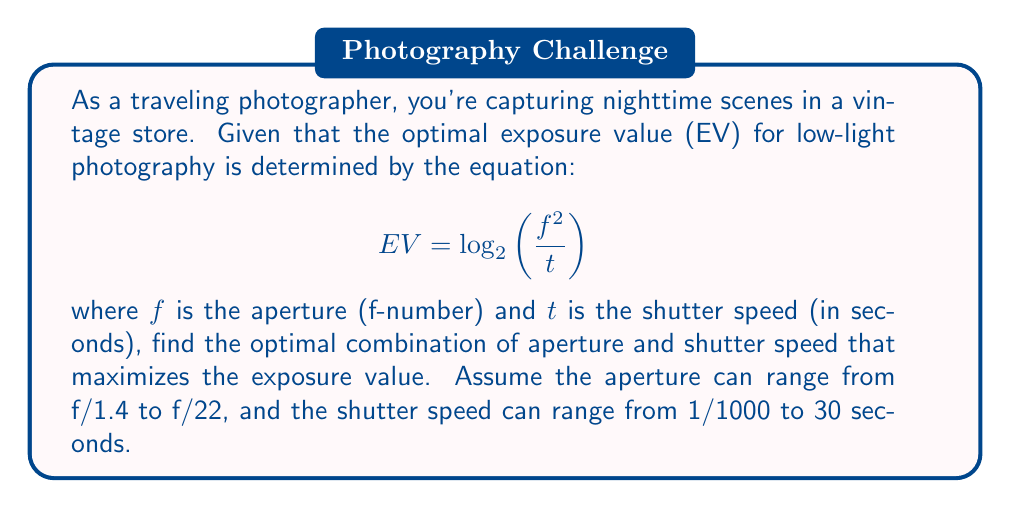Can you answer this question? To find the optimal combination of aperture and shutter speed, we need to maximize the exposure value (EV) function. Let's approach this step-by-step:

1) First, we express the EV function in terms of $f$ and $t$:

   $$EV(f,t) = \log_2\left(\frac{f^2}{t}\right)$$

2) To maximize this function, we need to find the partial derivatives with respect to $f$ and $t$ and set them equal to zero:

   $$\frac{\partial EV}{\partial f} = \frac{2}{f \ln 2} = 0$$
   $$\frac{\partial EV}{\partial t} = -\frac{1}{t \ln 2} = 0$$

3) From these equations, we can see that there are no finite values of $f$ and $t$ that satisfy both conditions simultaneously. This means that the maximum must occur at the boundaries of our allowed ranges.

4) Given the ranges:
   $1.4 \leq f \leq 22$
   $\frac{1}{1000} \leq t \leq 30$

5) To maximize EV, we need to maximize $\frac{f^2}{t}$. This occurs when $f$ is at its maximum and $t$ is at its minimum.

6) Therefore, the optimal values are:
   $f = 22$ (maximum aperture)
   $t = \frac{1}{1000}$ (minimum shutter speed)

7) We can calculate the maximum EV:

   $$EV_{max} = \log_2\left(\frac{22^2}{\frac{1}{1000}}\right) = \log_2(484000) \approx 18.88$$

This combination allows for the maximum amount of light to enter the camera while maintaining the shortest possible exposure time, which is ideal for capturing sharp images in low-light conditions.
Answer: The optimal combination is an aperture of f/22 and a shutter speed of 1/1000 second, resulting in a maximum exposure value of approximately 18.88. 